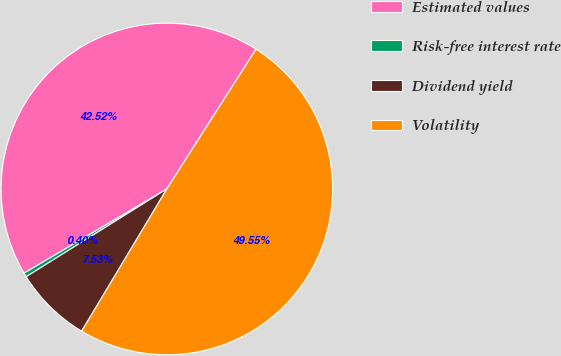Convert chart to OTSL. <chart><loc_0><loc_0><loc_500><loc_500><pie_chart><fcel>Estimated values<fcel>Risk-free interest rate<fcel>Dividend yield<fcel>Volatility<nl><fcel>42.52%<fcel>0.4%<fcel>7.53%<fcel>49.55%<nl></chart> 